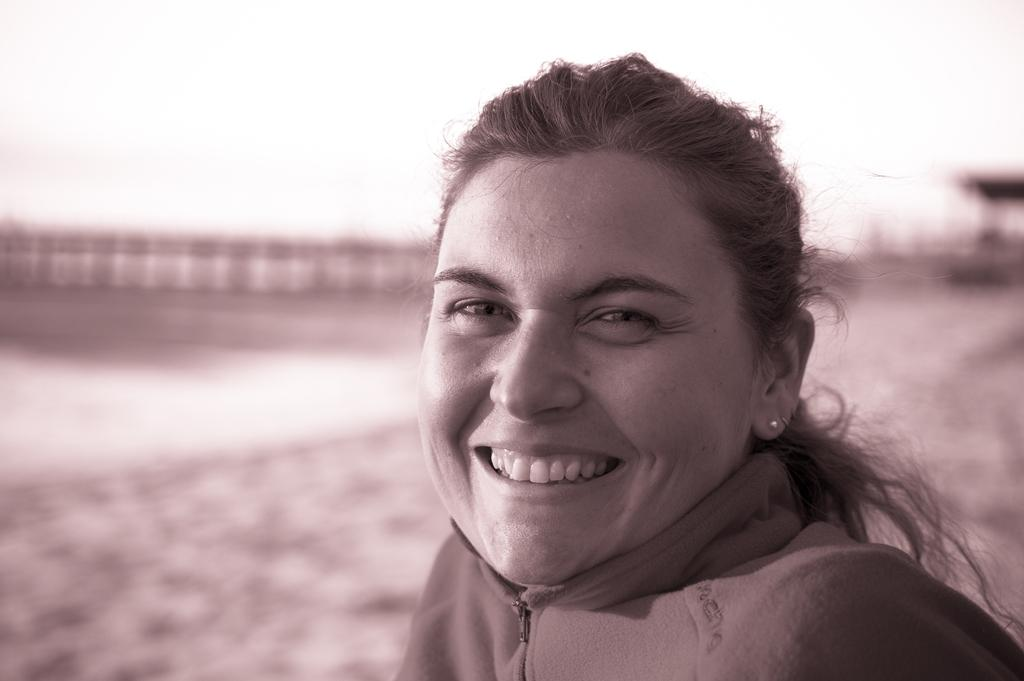What is the color scheme of the image? The image is black and white. Who is present in the image? There is a lady in the image. What is the lady doing in the image? The lady is smiling. Can you describe the background of the image? The background of the image is blurred. How many flies can be seen buzzing around the lady in the image? There are no flies present in the image. What type of experience does the lady have in the image? The image does not provide any information about the lady's experience. 